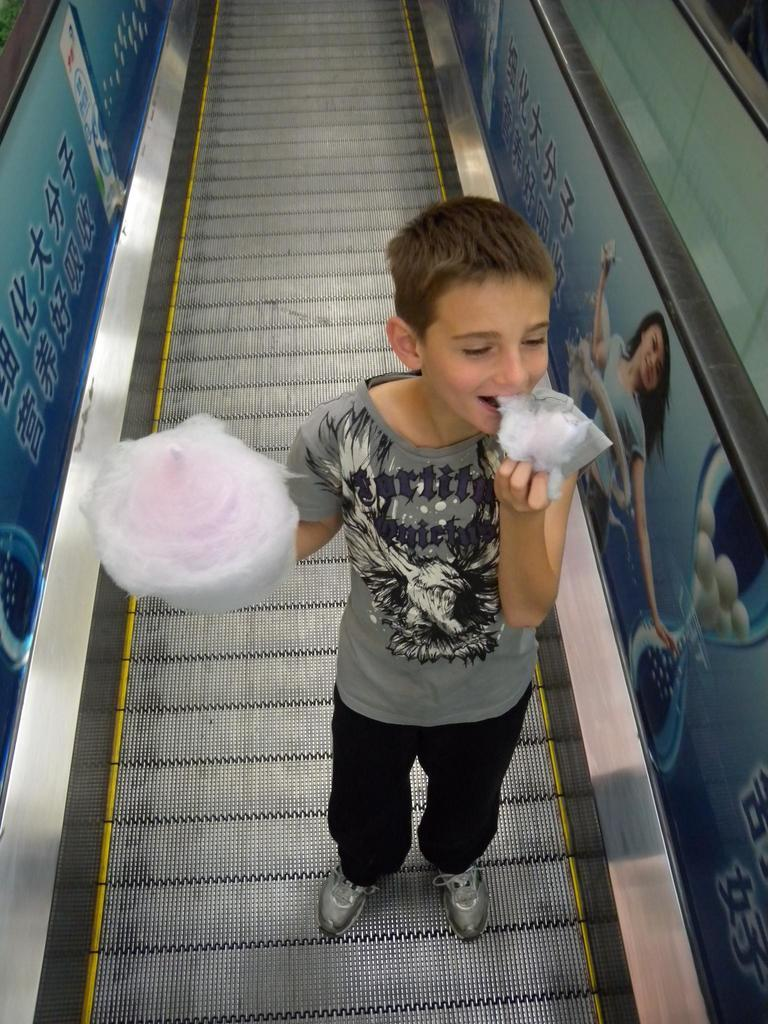What is the main subject of the image? The main subject of the image is a boy. Where is the boy located in the image? The boy is standing on an escalator in the image. What is the boy holding in the image? The boy is holding cotton candy in the image. What type of cabbage can be seen growing in the background of the image? There is no cabbage present in the image; it features a boy standing on an escalator and holding cotton candy. What is the aftermath of the boy's cotton candy experience in the image? The image does not depict any aftermath of the boy's cotton candy experience, as it only shows him holding the cotton candy. 